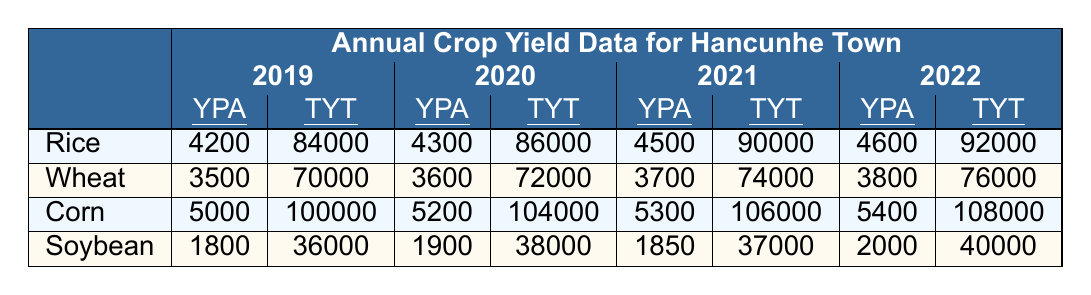What was the total yield in tons of corn in 2021? The table shows that in 2021 the total yield of corn was 106,000 tons.
Answer: 106,000 tons How much rice was produced in Hancunhe Town in 2020? Referring to the table, in 2020, the total yield of rice was 86,000 tons.
Answer: 86,000 tons What is the yield per acre of soybean in 2022? According to the table, the yield per acre of soybean in 2022 was 2,000.
Answer: 2,000 Which crop had the highest yield per acre in 2021? From the table, corn had the highest yield per acre in 2021 with 5,300.
Answer: Corn What was the average yield per acre of wheat from 2019 to 2022? The yields per acre of wheat are 3,500 (2019), 3,600 (2020), 3,700 (2021), and 3,800 (2022). Summing these gives 3,500 + 3,600 + 3,700 + 3,800 = 14,600. Dividing by 4 gives an average of 14,600 / 4 = 3,650.
Answer: 3,650 Which crop saw the largest percentage increase in total yield from 2019 to 2022? The total yields from 2019 to 2022 are as follows: rice (84,000 to 92,000), wheat (70,000 to 76,000), corn (100,000 to 108,000), and soybean (36,000 to 40,000). The percentage increases are: rice (9.52%), wheat (8.57%), corn (8%), and soybean (11.11%). Soybean had the largest increase of 11.11%.
Answer: Soybean Was the yield per acre of corn lower in 2020 compared to Rice in the same year? In 2020, corn had a yield per acre of 5,200 while rice had 4,300. Since 5,200 is greater than 4,300, the statement is false.
Answer: No What was the total yield in tons of soybeans across all years? The total yields for soybean are: 36,000 (2019), 38,000 (2020), 37,000 (2021), and 40,000 (2022). Summing these gives 36,000 + 38,000 + 37,000 + 40,000 = 151,000 tons.
Answer: 151,000 tons What is the difference in yield per acre of rice between 2019 and 2022? The yield per acre of rice in 2019 was 4,200 and in 2022 was 4,600. The difference is 4,600 - 4,200 = 400.
Answer: 400 In how many years did the yield per acre of wheat increase? In the table, 2019 (3,500) to 2020 (3,600), 2020 (3,600) to 2021 (3,700), and 2021 (3,700) to 2022 (3,800) all show increases, totaling 4 years with increases to 2022.
Answer: 4 years 